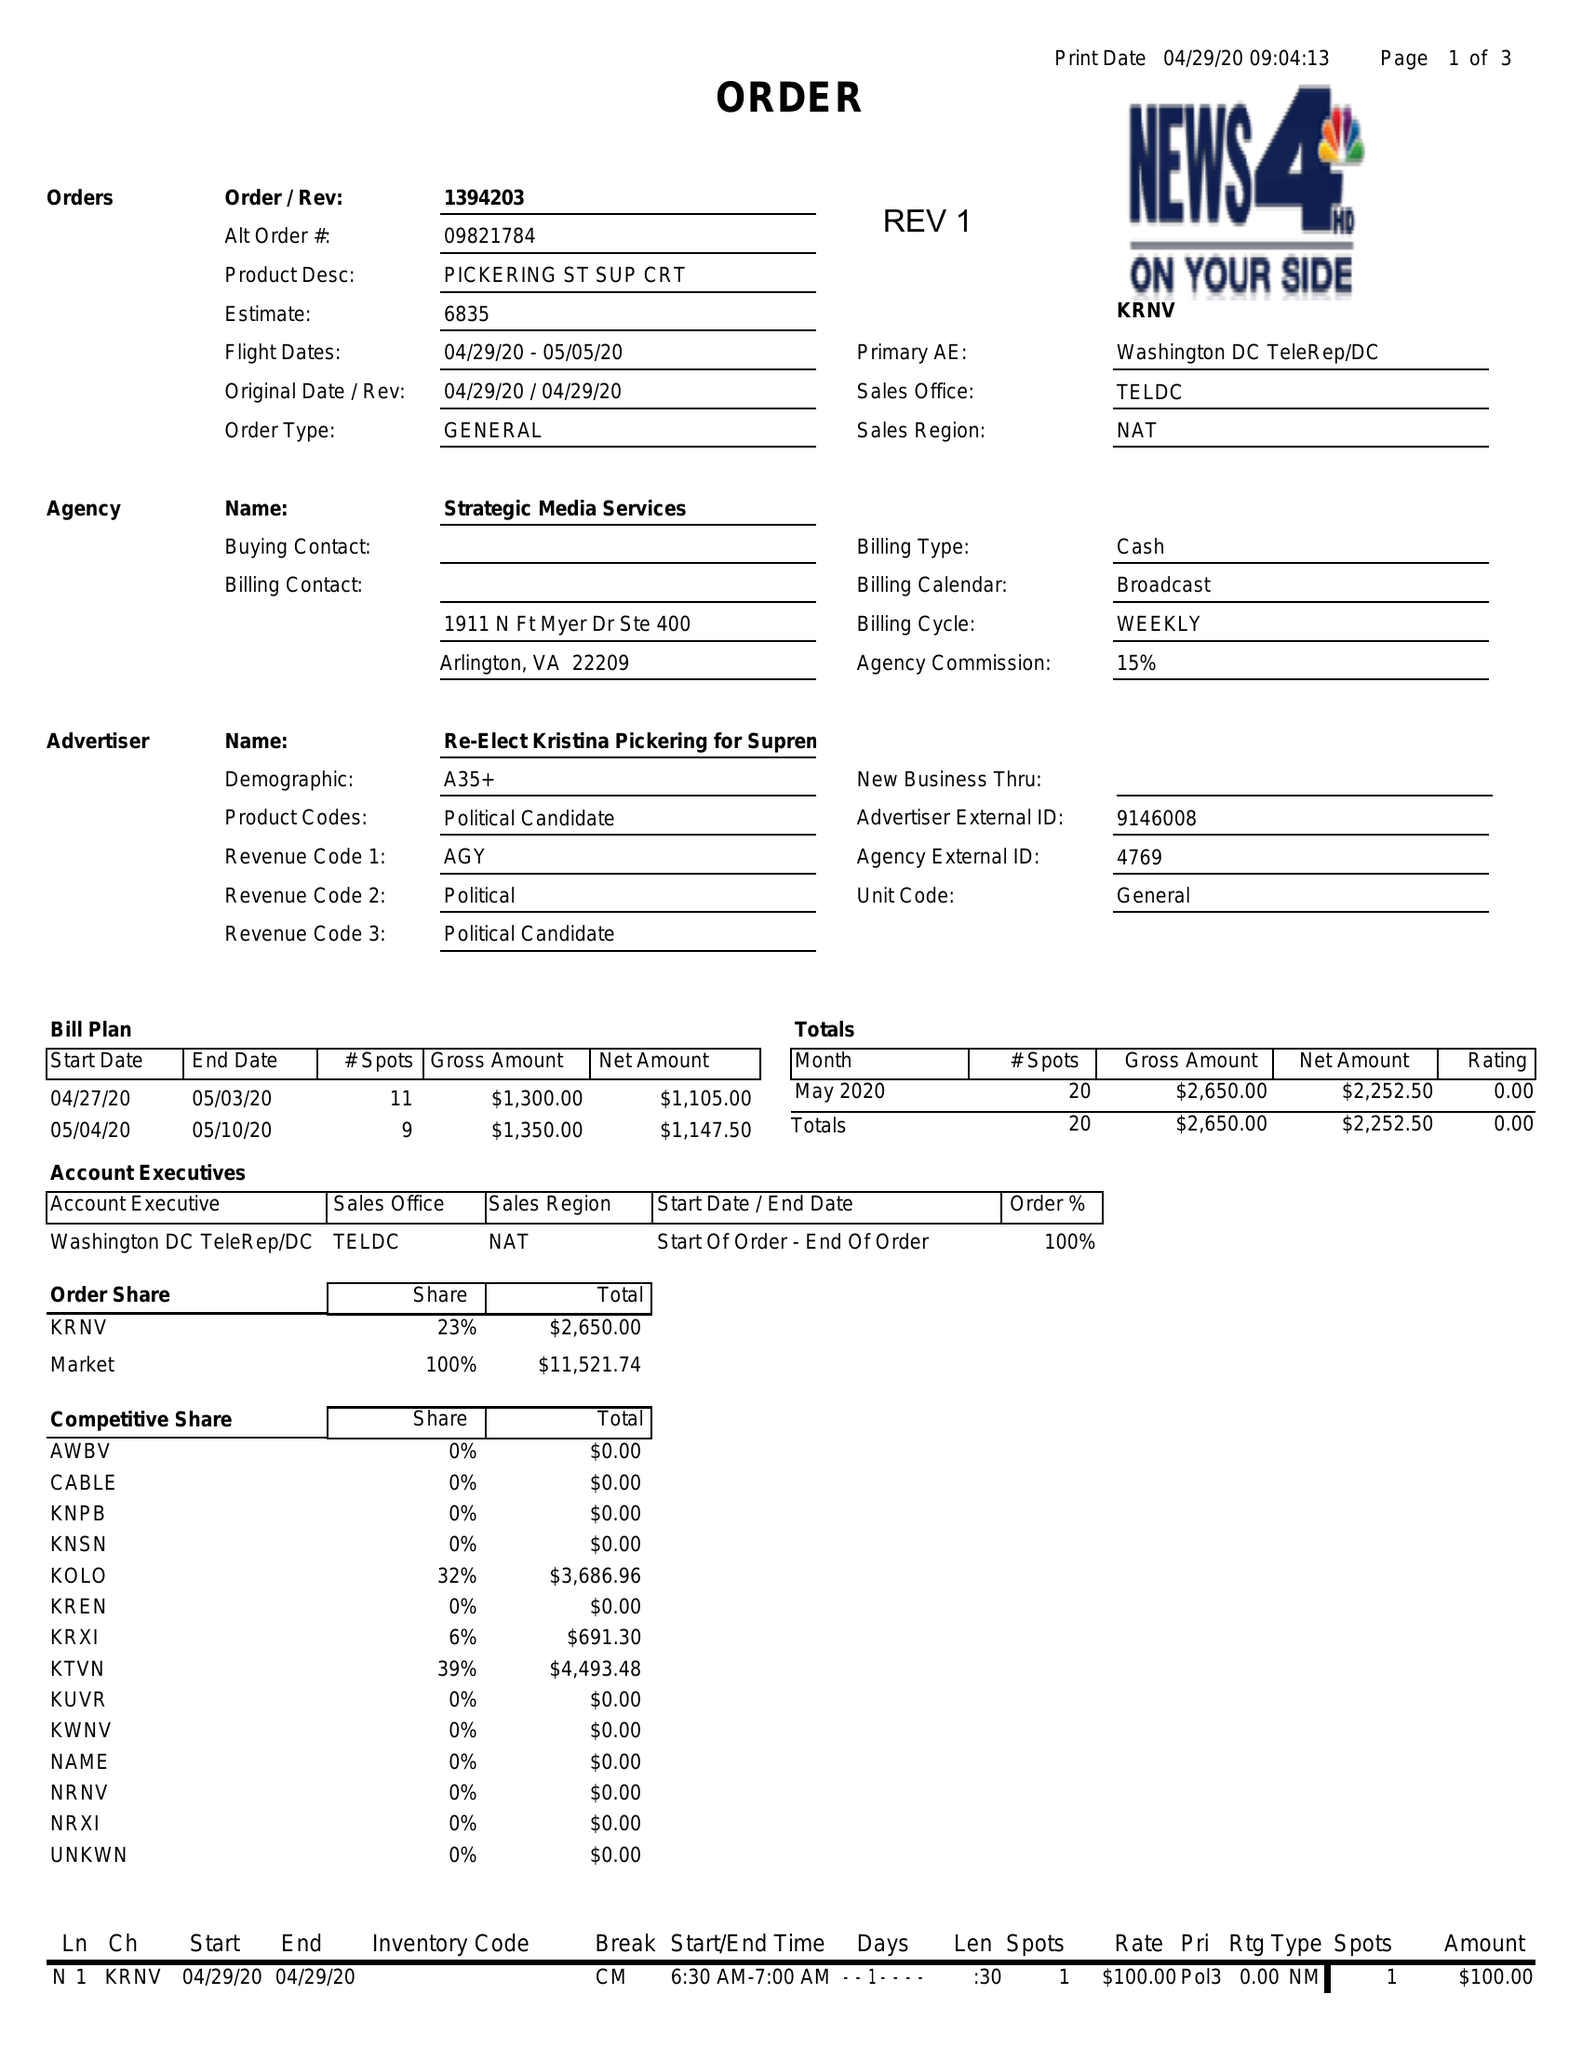What is the value for the contract_num?
Answer the question using a single word or phrase. 1394203 